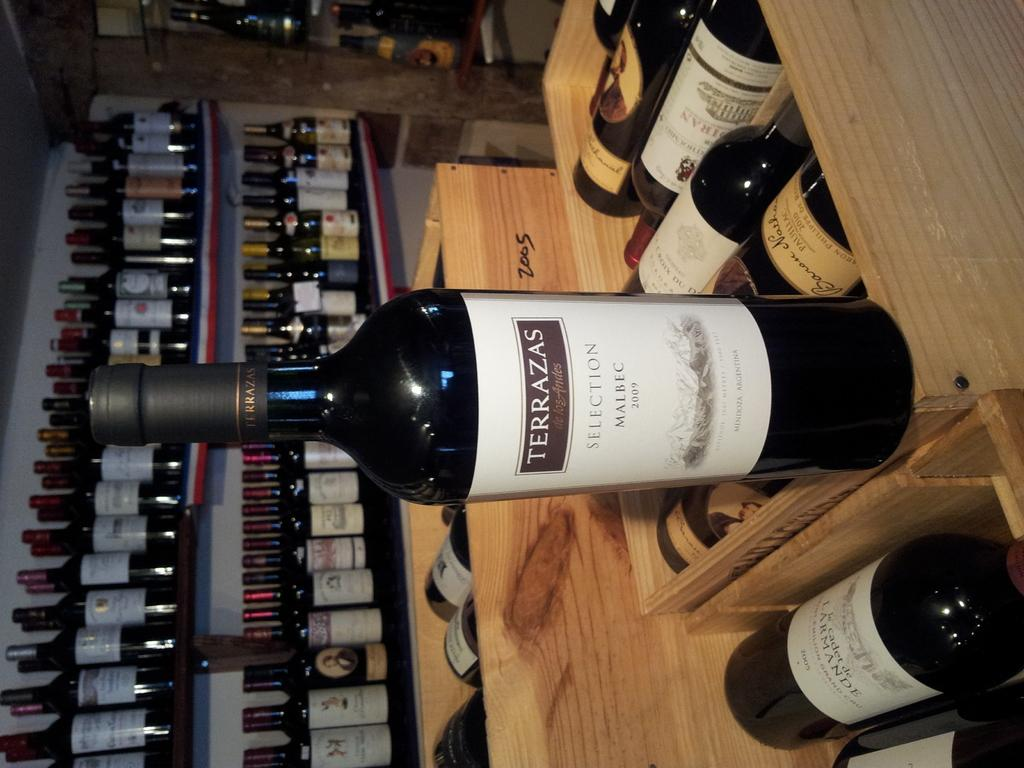What objects are visible in the image? There are bottles in the image. What is the color of the surface on which the bottles are placed? The bottles are on a brown color surface. Can you describe the background of the image? There are more bottles on racks in the background of the image. What type of curtain can be seen hanging from the bottles in the image? There is no curtain present in the image; it features bottles on a brown surface and additional bottles on racks in the background. 